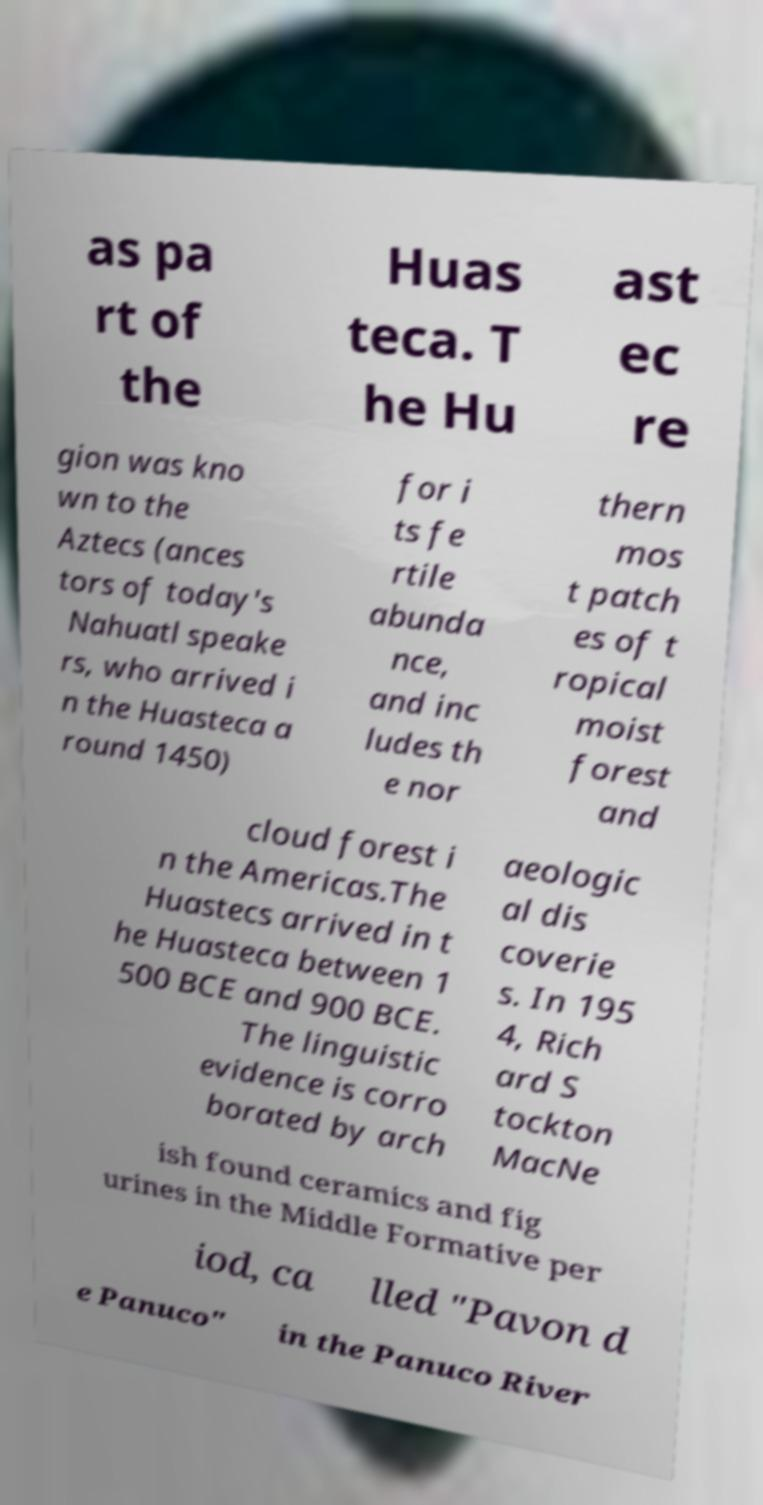Can you read and provide the text displayed in the image?This photo seems to have some interesting text. Can you extract and type it out for me? as pa rt of the Huas teca. T he Hu ast ec re gion was kno wn to the Aztecs (ances tors of today's Nahuatl speake rs, who arrived i n the Huasteca a round 1450) for i ts fe rtile abunda nce, and inc ludes th e nor thern mos t patch es of t ropical moist forest and cloud forest i n the Americas.The Huastecs arrived in t he Huasteca between 1 500 BCE and 900 BCE. The linguistic evidence is corro borated by arch aeologic al dis coverie s. In 195 4, Rich ard S tockton MacNe ish found ceramics and fig urines in the Middle Formative per iod, ca lled "Pavon d e Panuco" in the Panuco River 